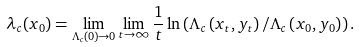<formula> <loc_0><loc_0><loc_500><loc_500>\lambda _ { c } ( { x } _ { 0 } ) = \lim _ { \Lambda _ { c } ( 0 ) \rightarrow 0 } \lim _ { t \rightarrow \infty } \frac { 1 } { t } \ln \left ( \Lambda _ { c } \left ( { x } _ { t } , { y } _ { t } \right ) / \Lambda _ { c } \left ( { x } _ { 0 } , { y } _ { 0 } \right ) \right ) .</formula> 